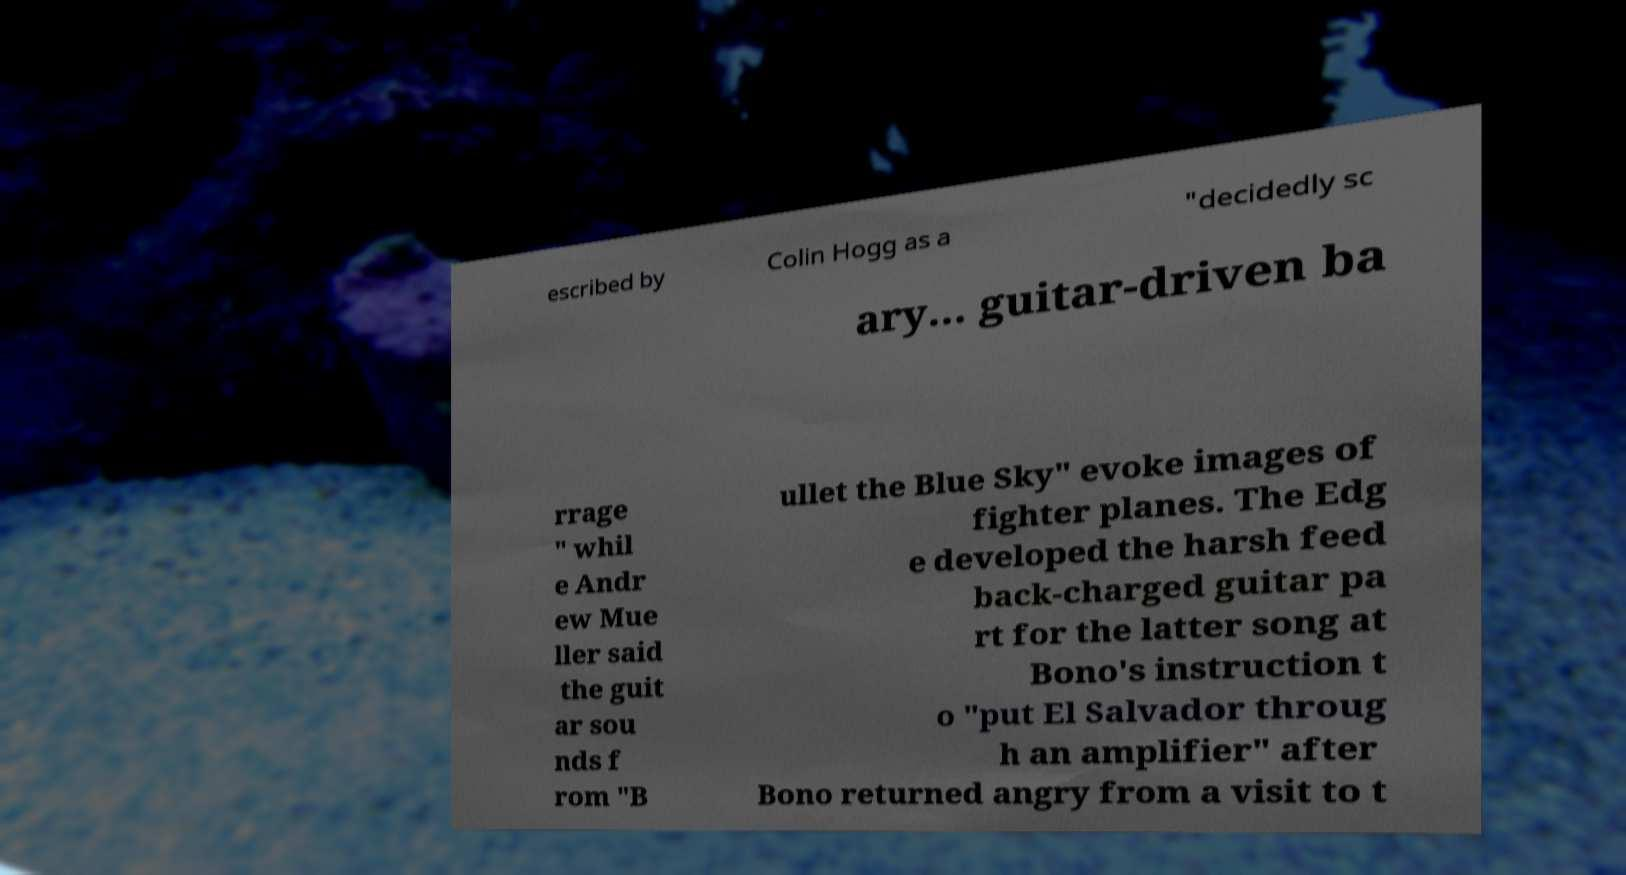I need the written content from this picture converted into text. Can you do that? escribed by Colin Hogg as a "decidedly sc ary... guitar-driven ba rrage " whil e Andr ew Mue ller said the guit ar sou nds f rom "B ullet the Blue Sky" evoke images of fighter planes. The Edg e developed the harsh feed back-charged guitar pa rt for the latter song at Bono's instruction t o "put El Salvador throug h an amplifier" after Bono returned angry from a visit to t 